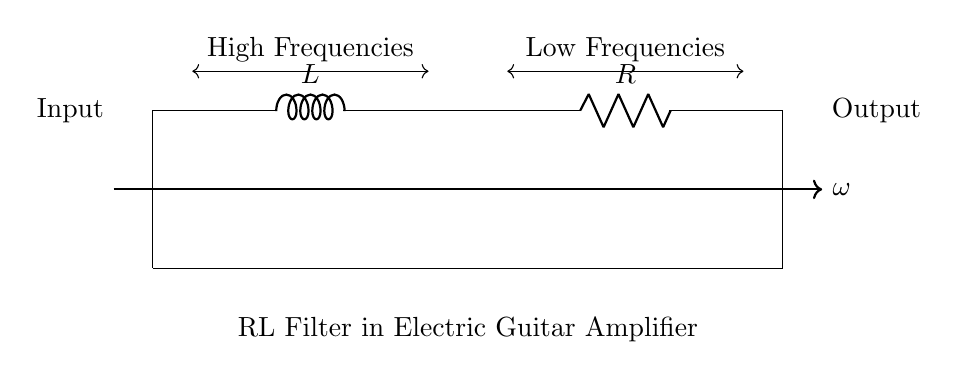What components are present in this circuit? The circuit contains a resistor and an inductor, as indicated by the symbols R and L in the diagram.
Answer: Resistor and Inductor What is the configuration of the components in this circuit? The components are connected in series, as there is a continuous path from the input to the output with no branching points.
Answer: Series What does the arrow at the top of the circuit indicate? The arrow indicates the direction of the frequency (ω), suggesting that the circuit behavior is affected by frequency changes, indicating its response to AC signals.
Answer: Frequency direction Which part of the circuit is associated with high frequencies? The section to the left of the inductor (L) is where high frequencies are being blocked or attenuated, while low frequencies pass through, as shown in the diagram.
Answer: Left of the inductor How does this RL filter affect low frequencies? The RL filter allows low frequencies to pass through more easily while attenuating high frequencies, which is characteristic of its behavior in filtering applications.
Answer: Passes low frequencies What type of filter is represented by this circuit? This circuit represents a low-pass filter, as it allows low-frequency signals to pass while blocking high frequencies.
Answer: Low-pass filter 